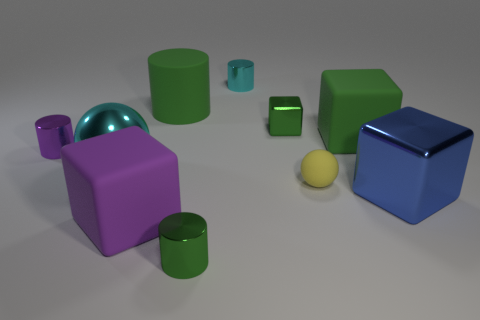Subtract 1 cylinders. How many cylinders are left? 3 Subtract all balls. How many objects are left? 8 Add 7 large cylinders. How many large cylinders are left? 8 Add 3 tiny purple matte things. How many tiny purple matte things exist? 3 Subtract 0 red blocks. How many objects are left? 10 Subtract all small green metal cylinders. Subtract all matte things. How many objects are left? 5 